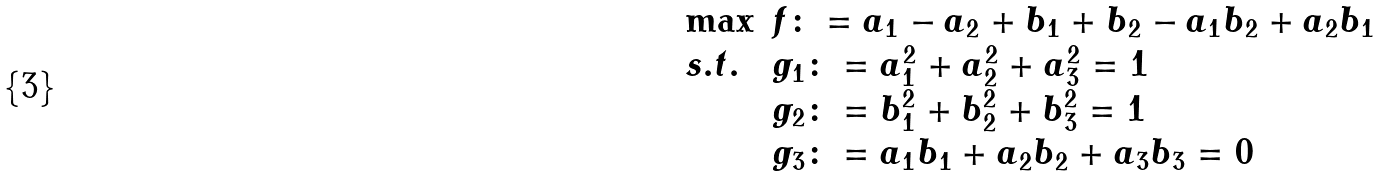Convert formula to latex. <formula><loc_0><loc_0><loc_500><loc_500>\begin{array} { l l } \max & f \colon = a _ { 1 } - a _ { 2 } + b _ { 1 } + b _ { 2 } - a _ { 1 } b _ { 2 } + a _ { 2 } b _ { 1 } \\ s . t . & g _ { 1 } \colon = a _ { 1 } ^ { 2 } + a _ { 2 } ^ { 2 } + a _ { 3 } ^ { 2 } = 1 \\ & g _ { 2 } \colon = b _ { 1 } ^ { 2 } + b _ { 2 } ^ { 2 } + b _ { 3 } ^ { 2 } = 1 \\ & g _ { 3 } \colon = a _ { 1 } b _ { 1 } + a _ { 2 } b _ { 2 } + a _ { 3 } b _ { 3 } = 0 \end{array}</formula> 